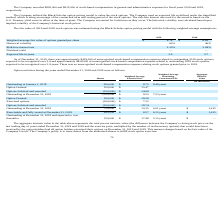According to Travelzoo's financial document, Which model did the company use to value the stock options? Black-Scholes option pricing model. The document states: "The Company utilized the Black-Scholes option pricing model to value the stock options. The Company used an expected life as defined under the simplif..." Also, What is the historical volatility used in 2019 and 2018 respectively? The document shows two values: 60% and 46%. From the document: "Historical volatility 60% 46% Historical volatility 60% 46%..." Also, What is the risk-free interest rate used in 2019 and 2018 respectively? The document shows two values: 2.10% and 2.84%. From the document: "Risk-free interest rate 2.10% 2.84% Risk-free interest rate 2.10% 2.84%..." Also, can you calculate: What is the average risk-free interest rate used in 2018 and 2019? To answer this question, I need to perform calculations using the financial data. The calculation is: (2.10+ 2.84)/2, which equals 2.47 (percentage). This is based on the information: "Risk-free interest rate 2.10% 2.84% Risk-free interest rate 2.10% 2.84%..." The key data points involved are: 2.10, 2.84. Also, can you calculate: What is the change in expected life in years used in the Black-Scholes model between 2018 and 2019? Based on the calculation: 3.6-5.7, the result is -2.1. This is based on the information: "Expected life in years 3.6 5.7 Expected life in years 3.6 5.7..." The key data points involved are: 3.6, 5.7. Additionally, Which year has a higher weighted-average fair value of options granted per share used in the Black-Scholes model? According to the financial document, 2019. The relevant text states: "The fair value of 2019 and 2018 stock options was estimated using the Black-Scholes option pricing model with the followin..." 